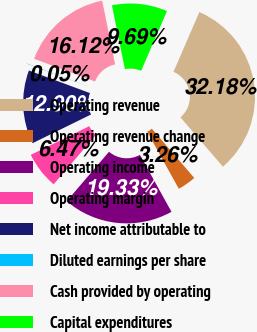<chart> <loc_0><loc_0><loc_500><loc_500><pie_chart><fcel>Operating revenue<fcel>Operating revenue change<fcel>Operating income<fcel>Operating margin<fcel>Net income attributable to<fcel>Diluted earnings per share<fcel>Cash provided by operating<fcel>Capital expenditures<nl><fcel>32.18%<fcel>3.26%<fcel>19.33%<fcel>6.47%<fcel>12.9%<fcel>0.05%<fcel>16.12%<fcel>9.69%<nl></chart> 